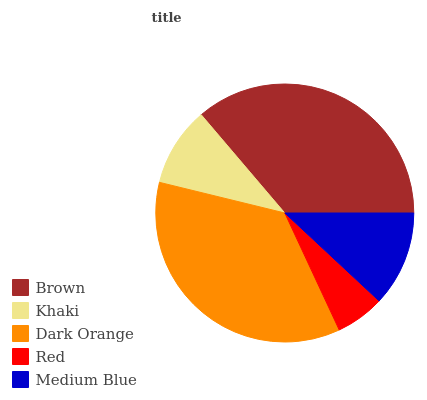Is Red the minimum?
Answer yes or no. Yes. Is Brown the maximum?
Answer yes or no. Yes. Is Khaki the minimum?
Answer yes or no. No. Is Khaki the maximum?
Answer yes or no. No. Is Brown greater than Khaki?
Answer yes or no. Yes. Is Khaki less than Brown?
Answer yes or no. Yes. Is Khaki greater than Brown?
Answer yes or no. No. Is Brown less than Khaki?
Answer yes or no. No. Is Medium Blue the high median?
Answer yes or no. Yes. Is Medium Blue the low median?
Answer yes or no. Yes. Is Red the high median?
Answer yes or no. No. Is Red the low median?
Answer yes or no. No. 